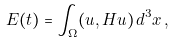<formula> <loc_0><loc_0><loc_500><loc_500>E ( t ) = \int _ { \Omega } ( u , H u ) \, d ^ { 3 } x \, ,</formula> 